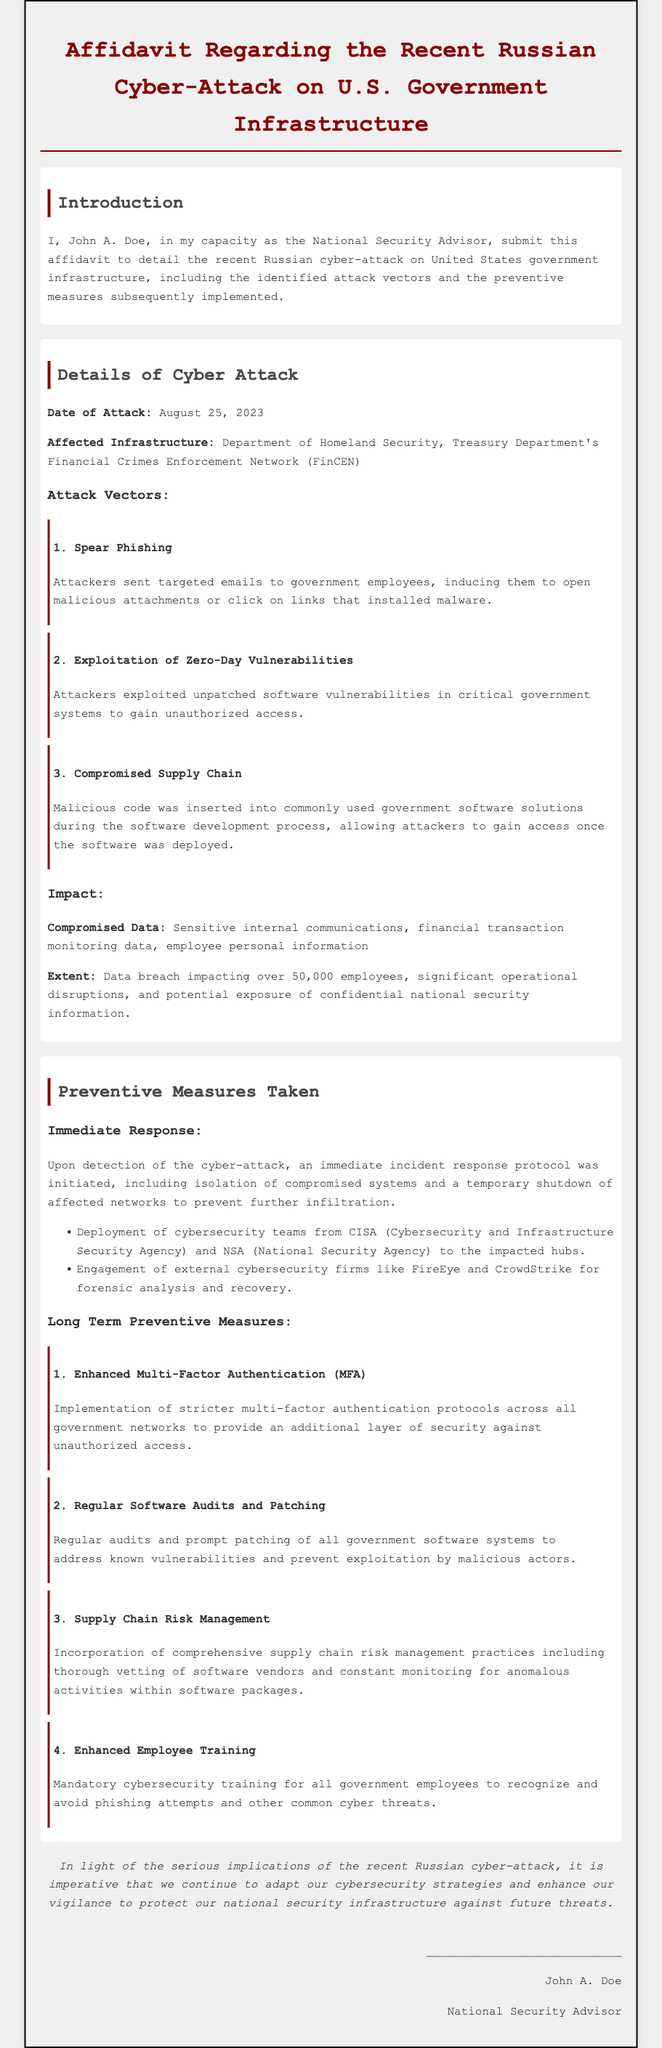What is the date of the attack? The date of the attack is clearly stated in the document under details of the cyber attack.
Answer: August 25, 2023 What departments were affected by the cyber-attack? The affidavit specifies the agencies impacted by the attack in the affected infrastructure section.
Answer: Department of Homeland Security, Treasury Department's Financial Crimes Enforcement Network (FinCEN) What impact did the data breach have on employees? The extent of the data breach details the number of employees affected and the situation created.
Answer: Over 50,000 employees What is one attack vector used in the cyber-attack? The document lists several attack vectors, specifying the methods used in the operation.
Answer: Spear Phishing Which agency deployed cybersecurity teams to the impacted hubs? The affidavit mentions the involvement of specific organizations in the immediate response section.
Answer: CISA (Cybersecurity and Infrastructure Security Agency) What type of training was mandated for government employees post-attack? The long-term preventive measures describe the nature of training instituted for employees.
Answer: Mandatory cybersecurity training What was the immediate response taken upon detection of the cyber-attack? The document outlines the initial actions taken to mitigate the attack after it was discovered.
Answer: Incident response protocol What measure was implemented for enhanced security against unauthorized access? The document provides specific long-term preventive measures focusing on security enhancements.
Answer: Enhanced Multi-Factor Authentication (MFA) What is emphasized as necessary to protect national security infrastructure? The conclusion highlights the importance of ongoing adaptation in cybersecurity strategies.
Answer: Continuing to adapt our cybersecurity strategies 